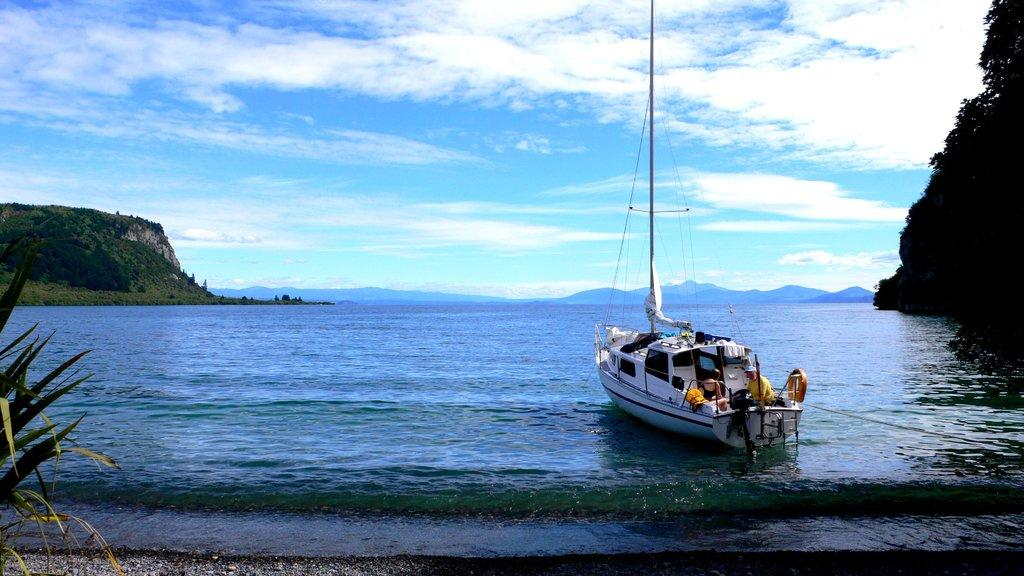What is the main subject of the image? The main subject of the image is a ship. What is the ship doing in the image? The ship is floating on the water. What can be seen in the background of the image? There are trees, hills, and clouds visible in the background of the image. What type of food is being served on the ship in the image? There is no food visible in the image, and the image does not show any activity related to serving food. 